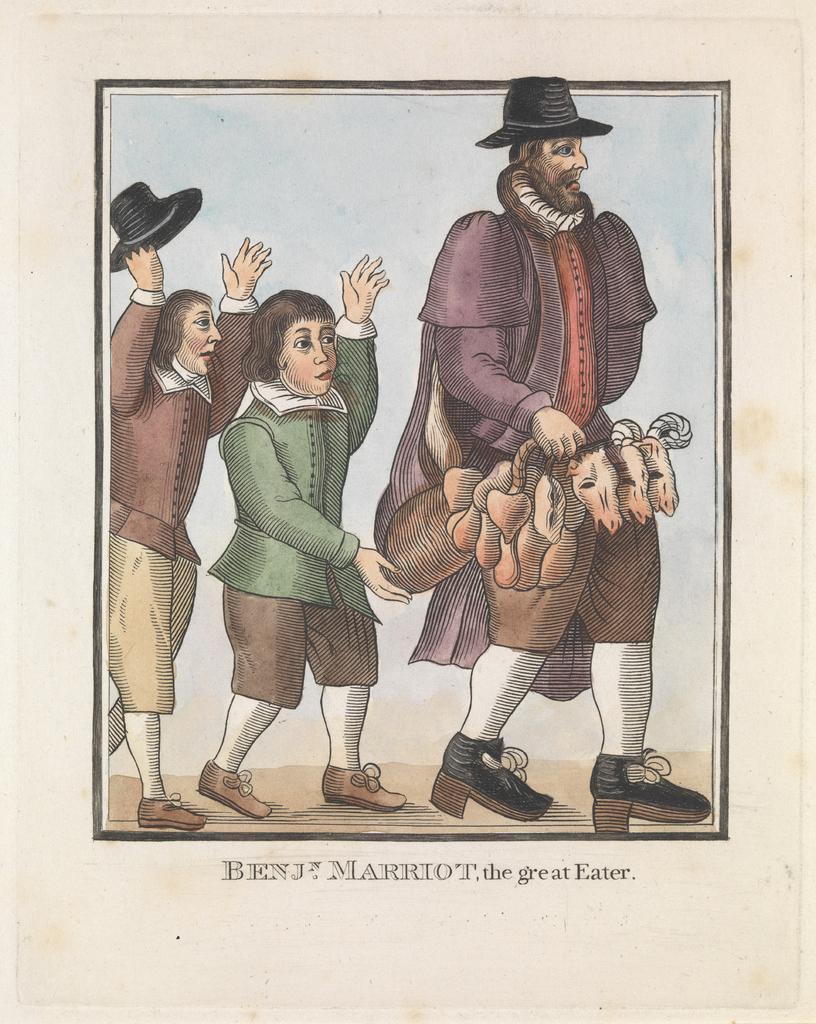Please provide a concise description of this image. In this image I can see three persons walking. In front the person is wearing green and brown color dress and I can see the white color background. 